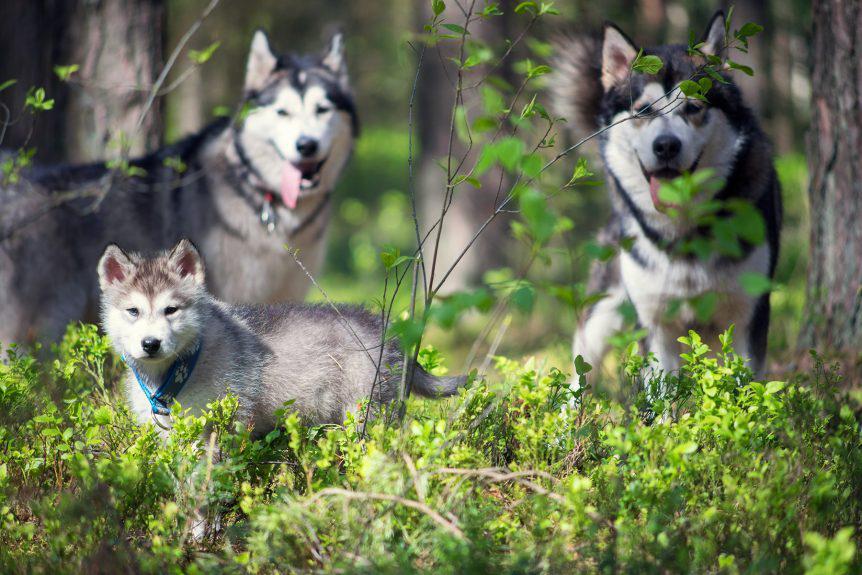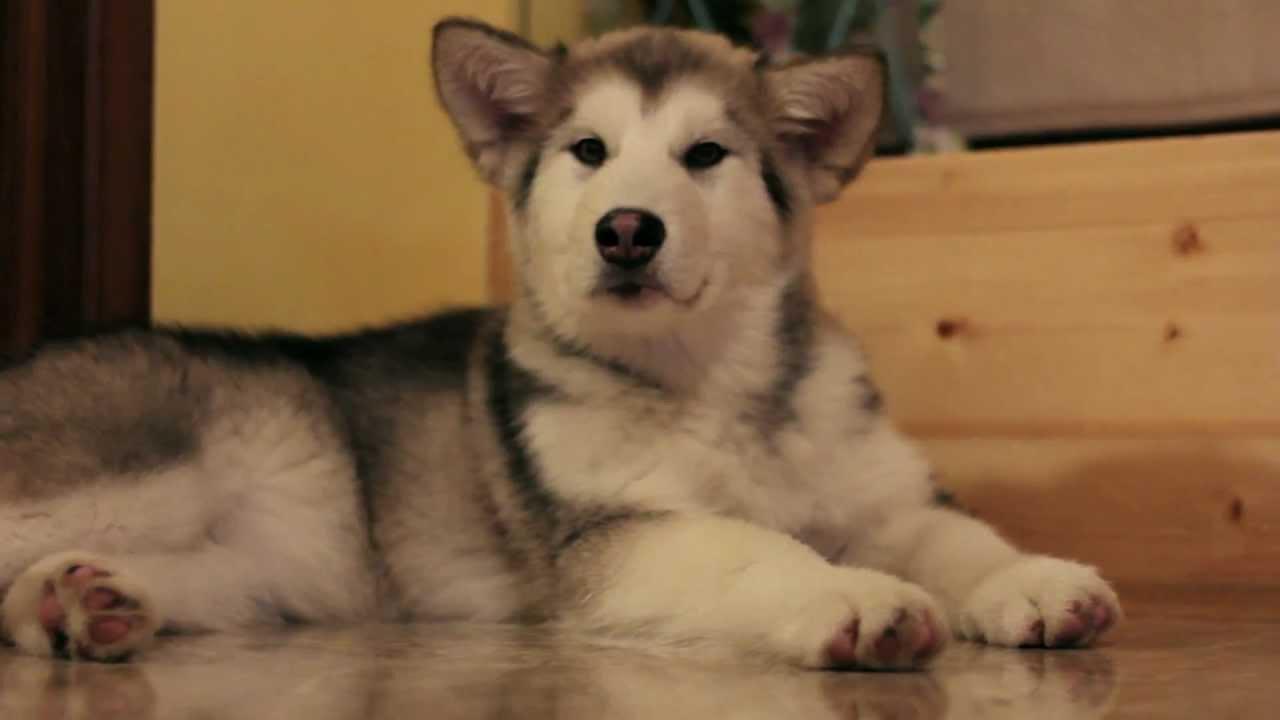The first image is the image on the left, the second image is the image on the right. Analyze the images presented: Is the assertion "The right image contains at least two dogs." valid? Answer yes or no. No. 